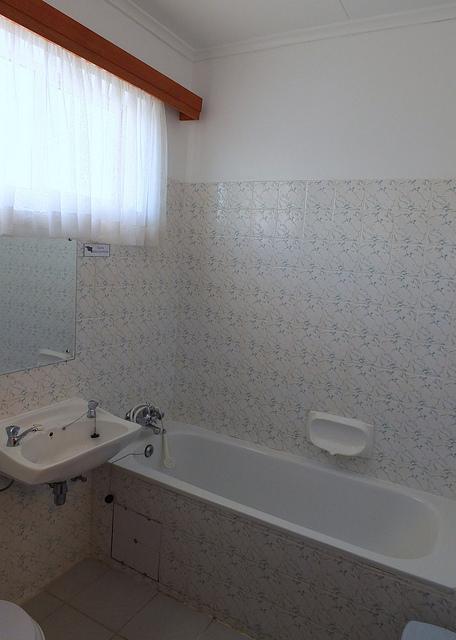What material covers the walls?
Give a very brief answer. Tile. How many curtains are hanging from the rod?
Write a very short answer. 1. Is the bathtub stained?
Concise answer only. No. Is there any soap in the bathroom?
Give a very brief answer. No. Are there any tools below the sink?
Answer briefly. No. Is there a bathtub in this room?
Be succinct. Yes. Is the room clean?
Give a very brief answer. Yes. Was this photo taken at someone's house or a hotel?
Concise answer only. House. Is the shower wall glass?
Give a very brief answer. No. What color is the tiles on the wall?
Give a very brief answer. White. What is this room probably used for?
Answer briefly. Bathing. Are the curtains closed?
Keep it brief. Yes. What is hanging on the wall behind the bathtub?
Keep it brief. Soap dish. Is there wallpaper?
Give a very brief answer. Yes. 